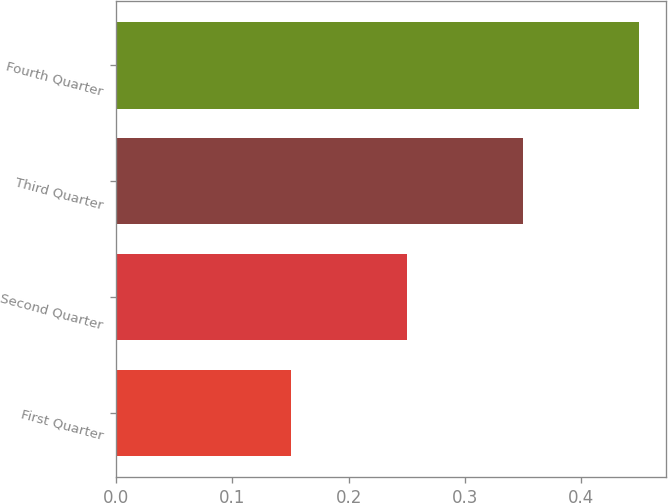Convert chart to OTSL. <chart><loc_0><loc_0><loc_500><loc_500><bar_chart><fcel>First Quarter<fcel>Second Quarter<fcel>Third Quarter<fcel>Fourth Quarter<nl><fcel>0.15<fcel>0.25<fcel>0.35<fcel>0.45<nl></chart> 